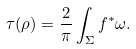Convert formula to latex. <formula><loc_0><loc_0><loc_500><loc_500>\tau ( \rho ) = \frac { 2 } { \pi } \int _ { \Sigma } f ^ { * } \omega .</formula> 